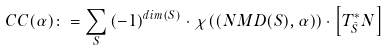Convert formula to latex. <formula><loc_0><loc_0><loc_500><loc_500>C C ( \alpha ) \colon = \sum _ { S } \, ( - 1 ) ^ { d i m ( S ) } \cdot \chi ( ( N M D ( S ) , \alpha ) ) \cdot \left [ T ^ { * } _ { \bar { S } } N \right ]</formula> 